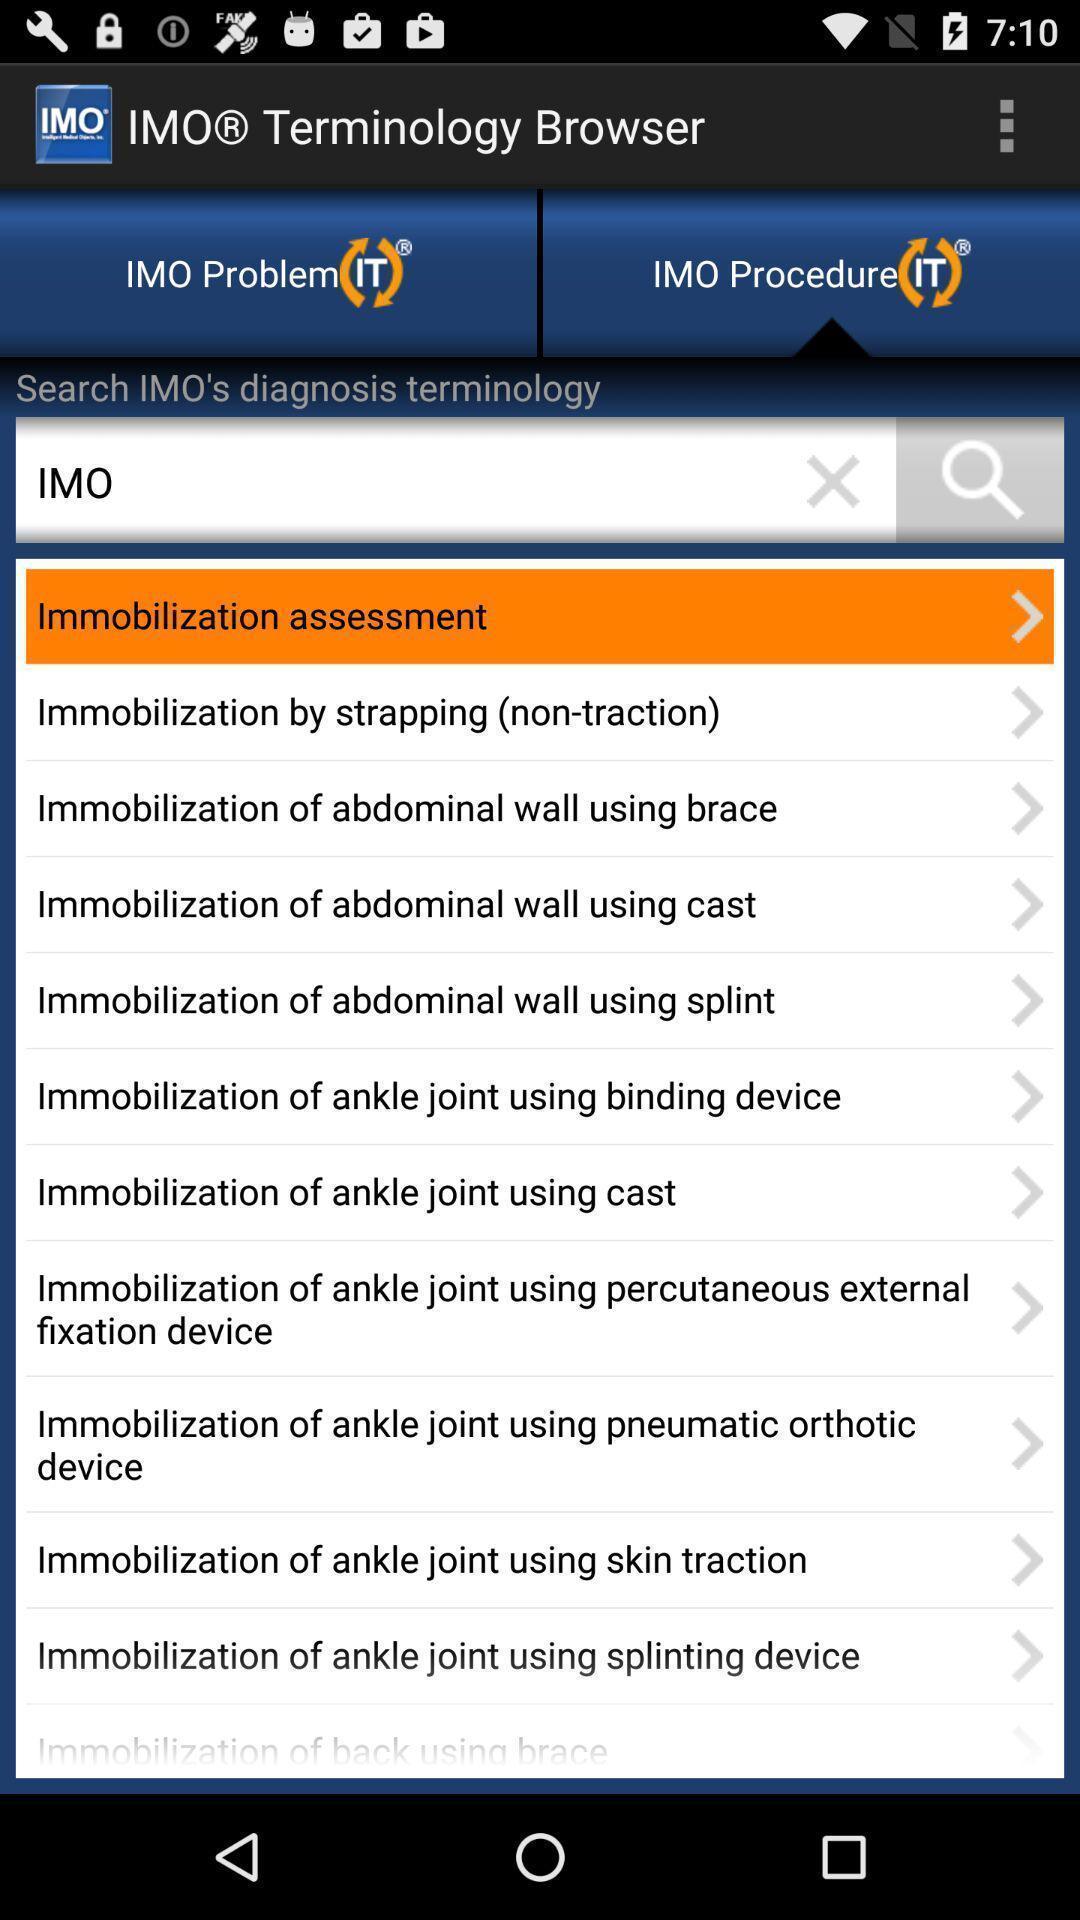Provide a textual representation of this image. Screen showing the listing in language learning app. 